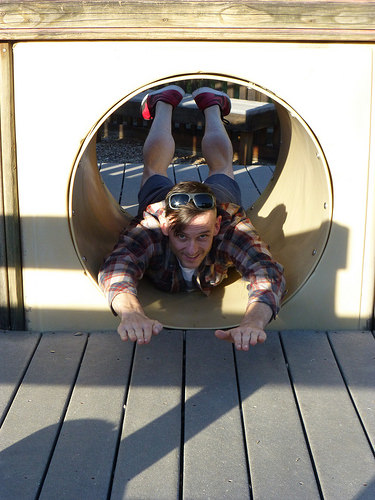<image>
Is the man in the tube? Yes. The man is contained within or inside the tube, showing a containment relationship. 